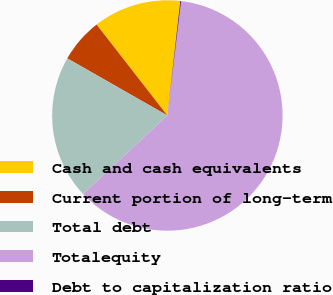<chart> <loc_0><loc_0><loc_500><loc_500><pie_chart><fcel>Cash and cash equivalents<fcel>Current portion of long-term<fcel>Total debt<fcel>Totalequity<fcel>Debt to capitalization ratio<nl><fcel>12.32%<fcel>6.22%<fcel>20.19%<fcel>61.16%<fcel>0.11%<nl></chart> 